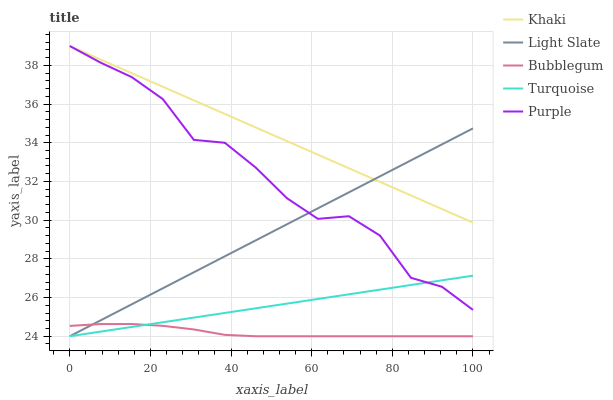Does Bubblegum have the minimum area under the curve?
Answer yes or no. Yes. Does Khaki have the maximum area under the curve?
Answer yes or no. Yes. Does Purple have the minimum area under the curve?
Answer yes or no. No. Does Purple have the maximum area under the curve?
Answer yes or no. No. Is Turquoise the smoothest?
Answer yes or no. Yes. Is Purple the roughest?
Answer yes or no. Yes. Is Purple the smoothest?
Answer yes or no. No. Is Turquoise the roughest?
Answer yes or no. No. Does Purple have the lowest value?
Answer yes or no. No. Does Turquoise have the highest value?
Answer yes or no. No. Is Turquoise less than Khaki?
Answer yes or no. Yes. Is Purple greater than Bubblegum?
Answer yes or no. Yes. Does Turquoise intersect Khaki?
Answer yes or no. No. 